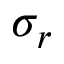Convert formula to latex. <formula><loc_0><loc_0><loc_500><loc_500>\sigma _ { r }</formula> 